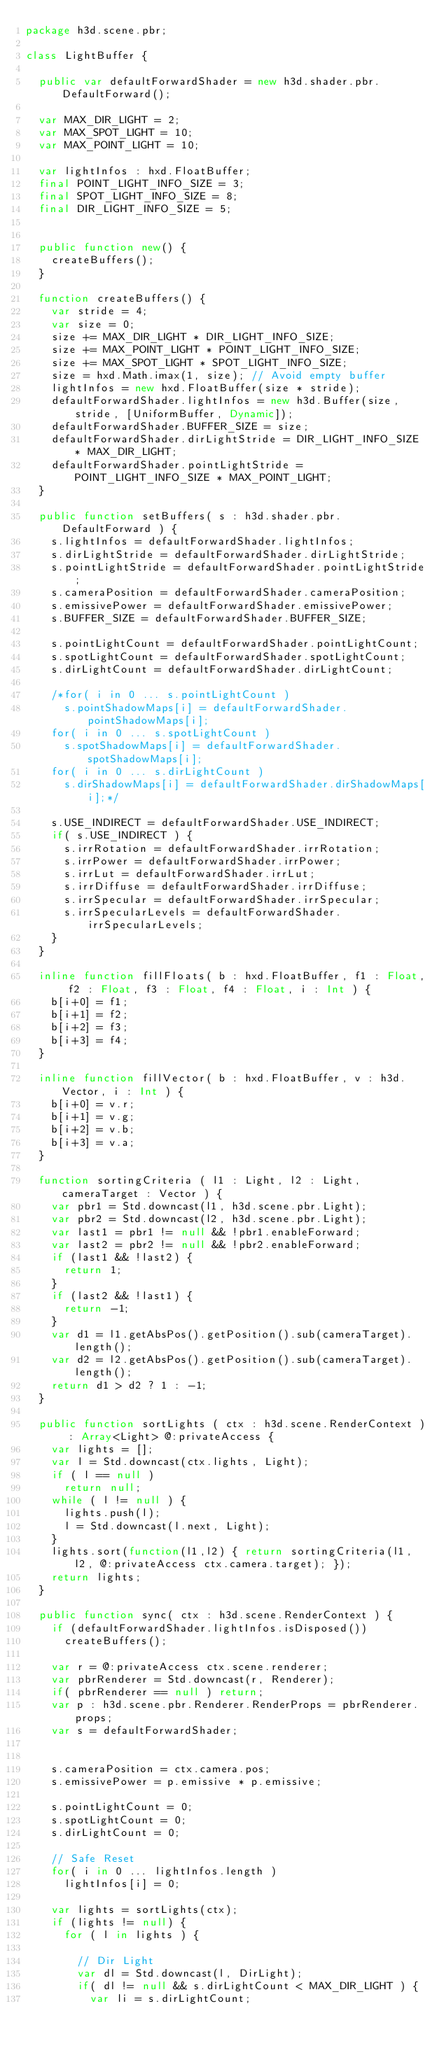Convert code to text. <code><loc_0><loc_0><loc_500><loc_500><_Haxe_>package h3d.scene.pbr;

class LightBuffer {

	public var defaultForwardShader = new h3d.shader.pbr.DefaultForward();

	var MAX_DIR_LIGHT = 2;
	var MAX_SPOT_LIGHT = 10;
	var MAX_POINT_LIGHT = 10;

	var lightInfos : hxd.FloatBuffer;
	final POINT_LIGHT_INFO_SIZE = 3;
	final SPOT_LIGHT_INFO_SIZE = 8;
	final DIR_LIGHT_INFO_SIZE = 5;


	public function new() {
		createBuffers();
	}

	function createBuffers() {
		var stride = 4;
		var size = 0;
		size += MAX_DIR_LIGHT * DIR_LIGHT_INFO_SIZE;
		size += MAX_POINT_LIGHT * POINT_LIGHT_INFO_SIZE;
		size += MAX_SPOT_LIGHT * SPOT_LIGHT_INFO_SIZE;
		size = hxd.Math.imax(1, size); // Avoid empty buffer
		lightInfos = new hxd.FloatBuffer(size * stride);
		defaultForwardShader.lightInfos = new h3d.Buffer(size, stride, [UniformBuffer, Dynamic]);
		defaultForwardShader.BUFFER_SIZE = size;
		defaultForwardShader.dirLightStride = DIR_LIGHT_INFO_SIZE * MAX_DIR_LIGHT;
		defaultForwardShader.pointLightStride = POINT_LIGHT_INFO_SIZE * MAX_POINT_LIGHT;
	}

	public function setBuffers( s : h3d.shader.pbr.DefaultForward ) {
		s.lightInfos = defaultForwardShader.lightInfos;
		s.dirLightStride = defaultForwardShader.dirLightStride;
		s.pointLightStride = defaultForwardShader.pointLightStride;
		s.cameraPosition = defaultForwardShader.cameraPosition;
		s.emissivePower = defaultForwardShader.emissivePower;
		s.BUFFER_SIZE = defaultForwardShader.BUFFER_SIZE;

		s.pointLightCount = defaultForwardShader.pointLightCount;
		s.spotLightCount = defaultForwardShader.spotLightCount;
		s.dirLightCount = defaultForwardShader.dirLightCount;

		/*for( i in 0 ... s.pointLightCount )
			s.pointShadowMaps[i] = defaultForwardShader.pointShadowMaps[i];
		for( i in 0 ... s.spotLightCount )
			s.spotShadowMaps[i] = defaultForwardShader.spotShadowMaps[i];
		for( i in 0 ... s.dirLightCount )
			s.dirShadowMaps[i] = defaultForwardShader.dirShadowMaps[i];*/

		s.USE_INDIRECT = defaultForwardShader.USE_INDIRECT;
		if( s.USE_INDIRECT ) {
			s.irrRotation = defaultForwardShader.irrRotation;
			s.irrPower = defaultForwardShader.irrPower;
			s.irrLut = defaultForwardShader.irrLut;
			s.irrDiffuse = defaultForwardShader.irrDiffuse;
			s.irrSpecular = defaultForwardShader.irrSpecular;
			s.irrSpecularLevels = defaultForwardShader.irrSpecularLevels;
		}
	}

	inline function fillFloats( b : hxd.FloatBuffer, f1 : Float, f2 : Float, f3 : Float, f4 : Float, i : Int ) {
		b[i+0] = f1;
		b[i+1] = f2;
		b[i+2] = f3;
		b[i+3] = f4;
	}

	inline function fillVector( b : hxd.FloatBuffer, v : h3d.Vector, i : Int ) {
		b[i+0] = v.r;
		b[i+1] = v.g;
		b[i+2] = v.b;
		b[i+3] = v.a;
	}

	function sortingCriteria ( l1 : Light, l2 : Light, cameraTarget : Vector ) {
		var pbr1 = Std.downcast(l1, h3d.scene.pbr.Light);
		var pbr2 = Std.downcast(l2, h3d.scene.pbr.Light);
		var last1 = pbr1 != null && !pbr1.enableForward;
		var last2 = pbr2 != null && !pbr2.enableForward;
		if (last1 && !last2) {
			return 1;
		}
		if (last2 && !last1) {
			return -1;
		}
		var d1 = l1.getAbsPos().getPosition().sub(cameraTarget).length();
		var d2 = l2.getAbsPos().getPosition().sub(cameraTarget).length();
		return d1 > d2 ? 1 : -1;
	}

	public function sortLights ( ctx : h3d.scene.RenderContext ) : Array<Light> @:privateAccess {
		var lights = [];
		var l = Std.downcast(ctx.lights, Light);
		if ( l == null )
			return null;
		while ( l != null ) {
			lights.push(l);
			l = Std.downcast(l.next, Light);
		}
		lights.sort(function(l1,l2) { return sortingCriteria(l1, l2, @:privateAccess ctx.camera.target); });
		return lights;
	}

	public function sync( ctx : h3d.scene.RenderContext ) {
		if (defaultForwardShader.lightInfos.isDisposed())
			createBuffers();

		var r = @:privateAccess ctx.scene.renderer;
		var pbrRenderer = Std.downcast(r, Renderer);
		if( pbrRenderer == null ) return;
		var p : h3d.scene.pbr.Renderer.RenderProps = pbrRenderer.props;
		var s = defaultForwardShader;


		s.cameraPosition = ctx.camera.pos;
		s.emissivePower = p.emissive * p.emissive;

		s.pointLightCount = 0;
		s.spotLightCount = 0;
		s.dirLightCount = 0;

		// Safe Reset
		for( i in 0 ... lightInfos.length )
			lightInfos[i] = 0;

		var lights = sortLights(ctx);
		if (lights != null) {
			for ( l in lights ) {

				// Dir Light
				var dl = Std.downcast(l, DirLight);
				if( dl != null && s.dirLightCount < MAX_DIR_LIGHT ) {
					var li = s.dirLightCount;</code> 